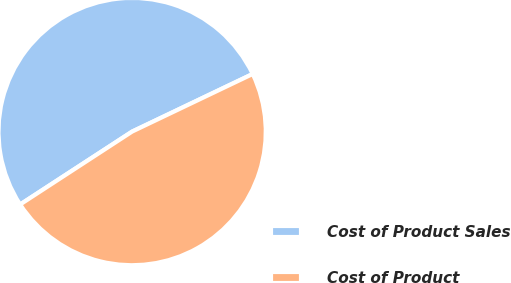Convert chart. <chart><loc_0><loc_0><loc_500><loc_500><pie_chart><fcel>Cost of Product Sales<fcel>Cost of Product<nl><fcel>52.09%<fcel>47.91%<nl></chart> 